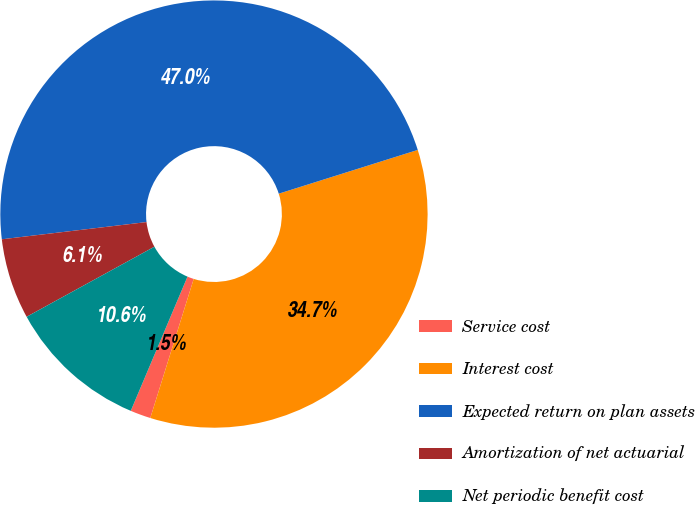<chart> <loc_0><loc_0><loc_500><loc_500><pie_chart><fcel>Service cost<fcel>Interest cost<fcel>Expected return on plan assets<fcel>Amortization of net actuarial<fcel>Net periodic benefit cost<nl><fcel>1.55%<fcel>34.67%<fcel>47.03%<fcel>6.1%<fcel>10.65%<nl></chart> 